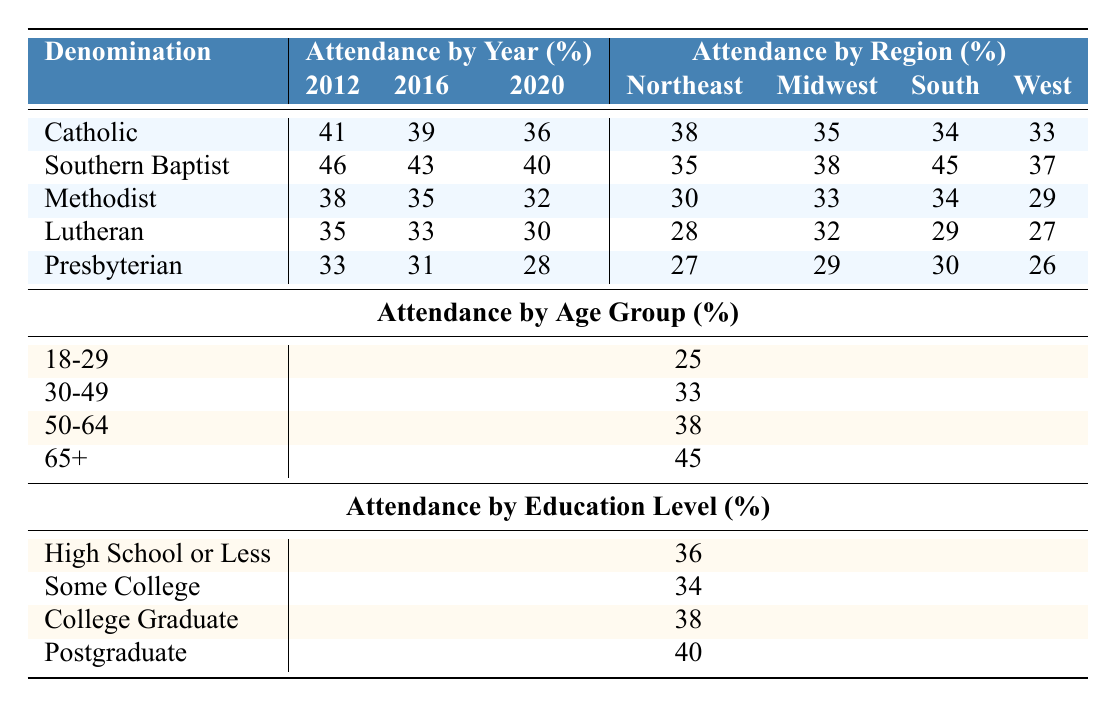What was the church attendance rate for Southern Baptist in 2016? According to the table, the attendance rate for Southern Baptist in 2016 is specifically listed as 43%.
Answer: 43% Which denomination had the highest attendance rate in 2012? In the table, the attendance rates for 2012 are 41% for Catholic, 46% for Southern Baptist, 38% for Methodist, 35% for Lutheran, and 33% for Presbyterian. The highest rate is 46% for Southern Baptist.
Answer: Southern Baptist What was the percentage decline in attendance for Catholic from 2012 to 2020? The attendance rate for Catholic in 2012 was 41% and in 2020 it was 36%. The decline is calculated as 41% - 36% = 5%.
Answer: 5% True or False: The attendance rate for Methodist was higher in 2016 than in 2020. The attendance rates for Methodist were 35% in 2016 and 32% in 2020. Since 35% is greater than 32%, the statement is true.
Answer: True What is the average church attendance rate for the South region across all denominations? The attendance rates for the South across denominations are 34% (Catholic), 45% (Southern Baptist), 34% (Methodist), 29% (Lutheran), and 30% (Presbyterian). Summing these rates gives 34 + 45 + 34 + 29 + 30 = 172 and dividing by 5 gives an average of 172/5 = 34.4%.
Answer: 34.4% Which age group has the lowest attendance rate and what is that rate? The age groups listed have attendance rates of 25% (18-29), 33% (30-49), 38% (50-64), and 45% (65+). The lowest rate is 25% for the 18-29 age group.
Answer: 25% How does the attendance rate for Postgraduate compare to that for High School or Less? The attendance rate for Postgraduate is 40% while for High School or Less, it is 36%. The difference is 40% - 36% = 4%, indicating that Postgraduates attend at a rate of 4% higher.
Answer: 4% higher If you combine the attendance rates of the 50-64 age group and the 30-49 age group, what is the total? The attendance rate for 50-64 is 38% and for 30-49 is 33%. Adding these gives a total of 38% + 33% = 71%.
Answer: 71% What is the relationship between educational attainment and church attendance rates apparent in the table? The table shows that as educational attainment increases, attendance rates also tend to increase: High School or Less (36%), Some College (34%), College Graduate (38%), Postgraduate (40%). This suggests a positive correlation between education level and attendance.
Answer: Positive correlation Was the attendance rate for the Lutheran denomination in 2020 less than any of the regional rates? In 2020, the attendance rate for Lutheran was 30%. The regional rates are Northeast (28%), Midwest (32%), South (29%), and West (27%). Since 30% is above the rates for all regions, the statement is false.
Answer: False 